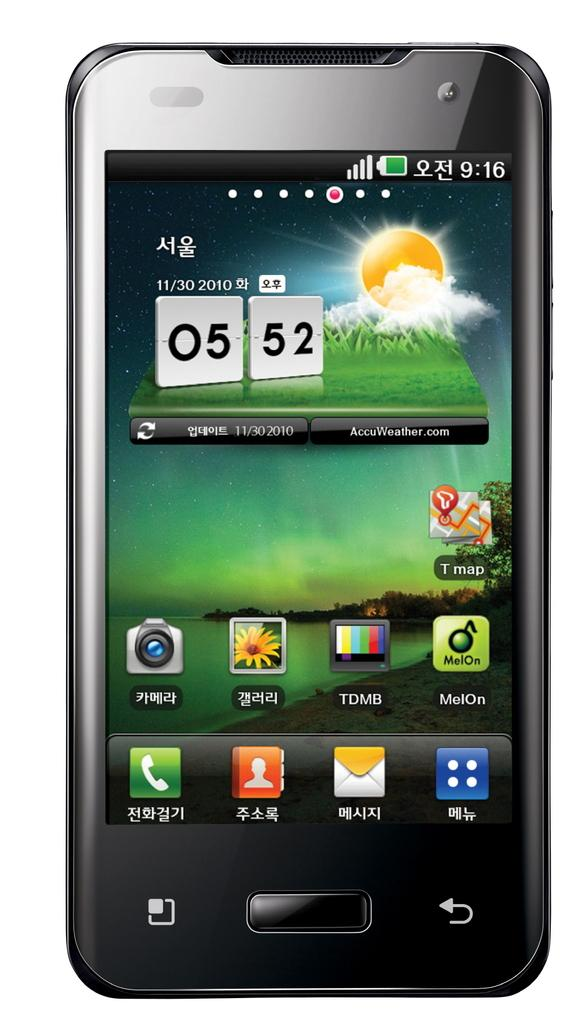Provide a one-sentence caption for the provided image. An Asian brand of smartphone displays its home screen featuring the time 05:52 on 11/30/2010. 